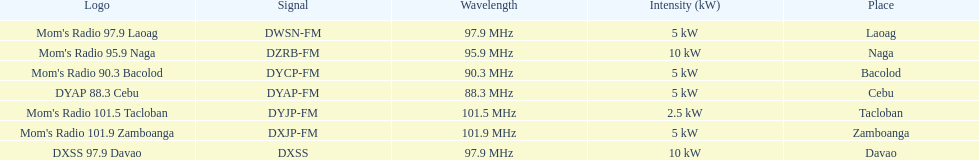What is the total number of stations with frequencies above 100 mhz? 2. 